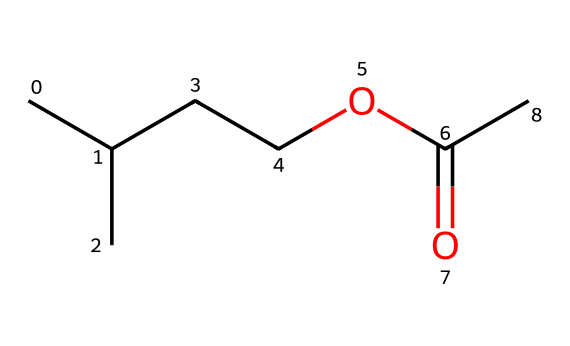What is the molecular formula of isoamyl acetate? To determine the molecular formula, count the number of each type of atom present in the SMILES representation. The chemical contains 5 carbon atoms (C), 10 hydrogen atoms (H), and 2 oxygen atoms (O). Thus, the molecular formula is C5H10O2.
Answer: C5H10O2 How many carbon atoms are in isoamyl acetate? From the SMILES structure, we can identify that there are 5 carbon atoms, as represented by the letters 'C' in the structure.
Answer: 5 What functional group is present in isoamyl acetate? The SMILES shows a carbonyl group (C=O) and an ether linkage (C-O), which together characterize it as an ester. This distinct grouping is what defines the molecular structure of esters like isoamyl acetate.
Answer: ester What type of odor does isoamyl acetate impart to cheese? Isoamyl acetate is known for its banana-like aroma, which is a characteristic scent associated with this specific ester, making it noticeable in certain cheeses.
Answer: banana Which part of the molecule contributes to its aroma? The ester functional group (specifically the carbonyl and adjacent ether bond) is crucial, as it's linked to the volatile compounds contributing to the scent; thus, isoamyl acetate's structure is essential for imparting that fruity aroma.
Answer: ester functional group What is the significance of isoamyl acetate in cheesemaking? Isoamyl acetate is significant in cheesemaking due to its role in flavor development, particularly for cheeses that are intended to have fruity or banana-like aromas, enhancing the sensory profile of the final product.
Answer: flavor development How many oxygen atoms are present in isoamyl acetate? In the provided SMILES structure, we can see two instances of the letter 'O', indicating there are two oxygen atoms present in the molecule.
Answer: 2 